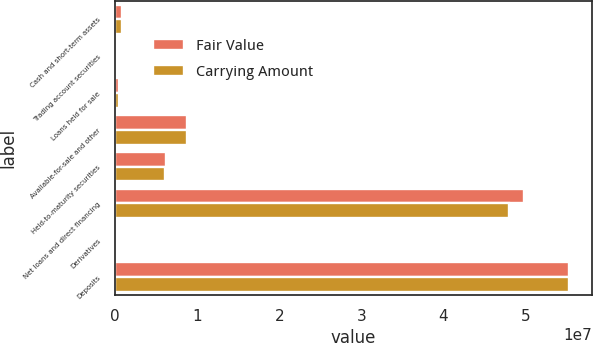<chart> <loc_0><loc_0><loc_500><loc_500><stacked_bar_chart><ecel><fcel>Cash and short-term assets<fcel>Trading account securities<fcel>Loans held for sale<fcel>Available-for-sale and other<fcel>Held-to-maturity securities<fcel>Net loans and direct financing<fcel>Derivatives<fcel>Deposits<nl><fcel>Fair Value<fcel>898994<fcel>36997<fcel>474621<fcel>8.77544e+06<fcel>6.15959e+06<fcel>4.97433e+07<fcel>274872<fcel>5.5295e+07<nl><fcel>Carrying Amount<fcel>898994<fcel>36997<fcel>484511<fcel>8.77544e+06<fcel>6.13546e+06<fcel>4.8025e+07<fcel>274872<fcel>5.52994e+07<nl></chart> 